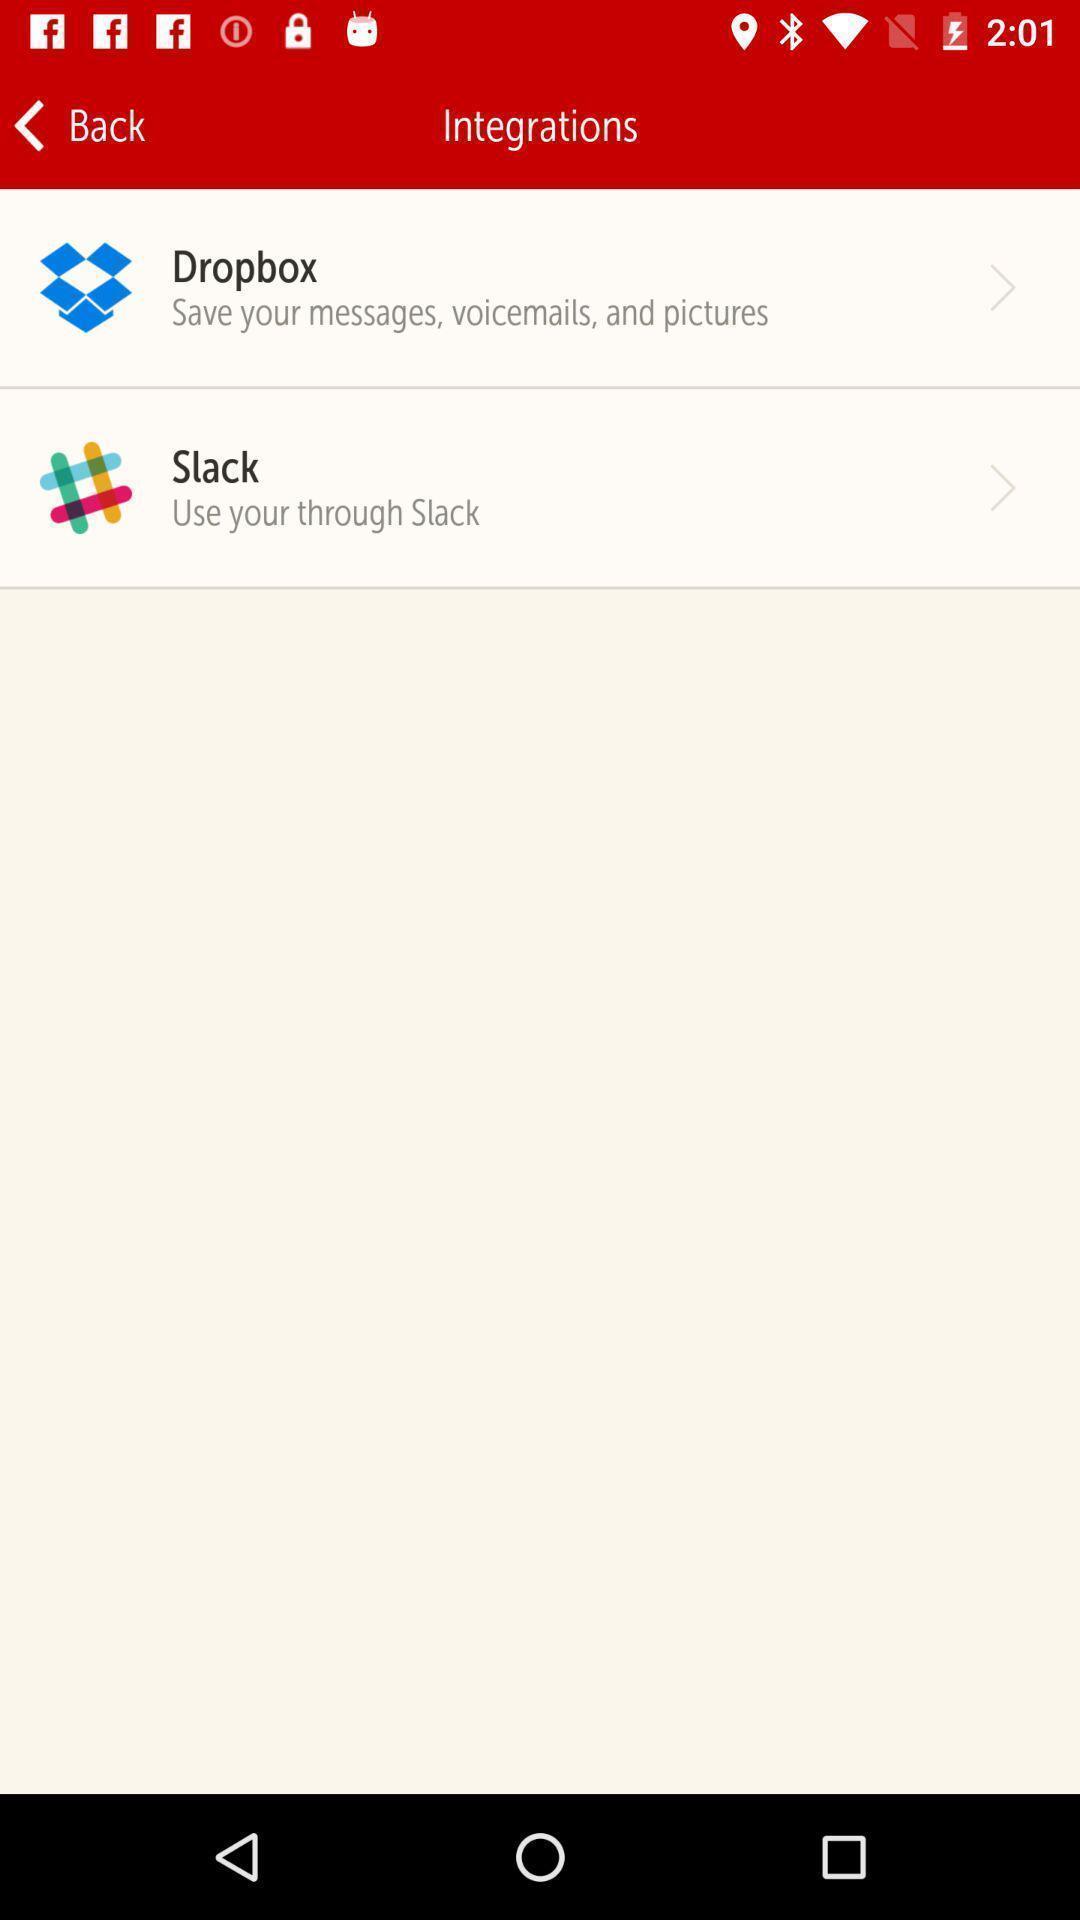Describe the visual elements of this screenshot. Screen shows details. 